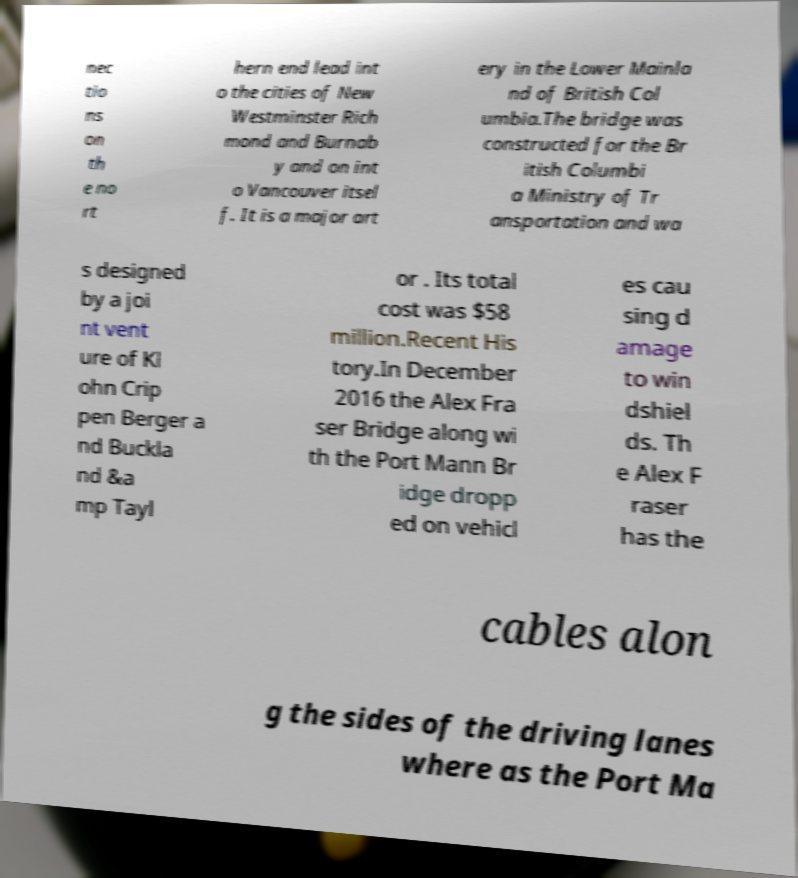Can you accurately transcribe the text from the provided image for me? nec tio ns on th e no rt hern end lead int o the cities of New Westminster Rich mond and Burnab y and on int o Vancouver itsel f. It is a major art ery in the Lower Mainla nd of British Col umbia.The bridge was constructed for the Br itish Columbi a Ministry of Tr ansportation and wa s designed by a joi nt vent ure of Kl ohn Crip pen Berger a nd Buckla nd &a mp Tayl or . Its total cost was $58 million.Recent His tory.In December 2016 the Alex Fra ser Bridge along wi th the Port Mann Br idge dropp ed on vehicl es cau sing d amage to win dshiel ds. Th e Alex F raser has the cables alon g the sides of the driving lanes where as the Port Ma 